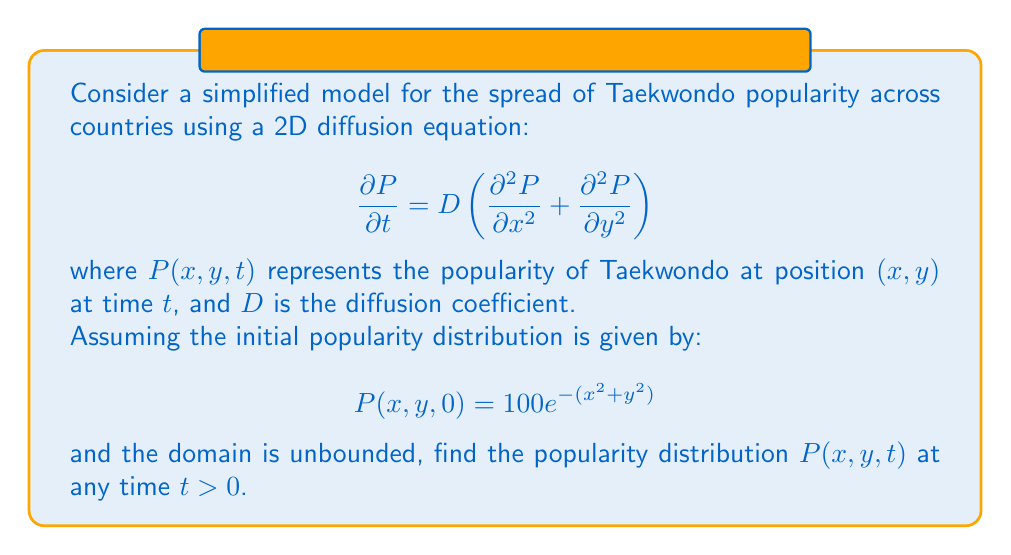Give your solution to this math problem. To solve this problem, we'll follow these steps:

1) Recognize that this is a 2D diffusion equation with an initial condition.

2) The solution to the 2D diffusion equation with an initial condition $P(x,y,0) = f(x,y)$ is given by:

   $$P(x,y,t) = \frac{1}{4\pi Dt}\int_{-\infty}^{\infty}\int_{-\infty}^{\infty} f(\xi,\eta)e^{-\frac{(x-\xi)^2+(y-\eta)^2}{4Dt}}d\xi d\eta$$

3) In our case, $f(x,y) = 100e^{-(x^2+y^2)}$

4) Substituting this into the solution:

   $$P(x,y,t) = \frac{100}{4\pi Dt}\int_{-\infty}^{\infty}\int_{-\infty}^{\infty} e^{-(\xi^2+\eta^2)}e^{-\frac{(x-\xi)^2+(y-\eta)^2}{4Dt}}d\xi d\eta$$

5) This integral can be evaluated by completing the square in the exponent. After some algebra, we get:

   $$P(x,y,t) = \frac{100}{1+4Dt}e^{-\frac{x^2+y^2}{1+4Dt}}$$

This is the solution for the popularity distribution at any time $t > 0$.
Answer: $$P(x,y,t) = \frac{100}{1+4Dt}e^{-\frac{x^2+y^2}{1+4Dt}}$$ 